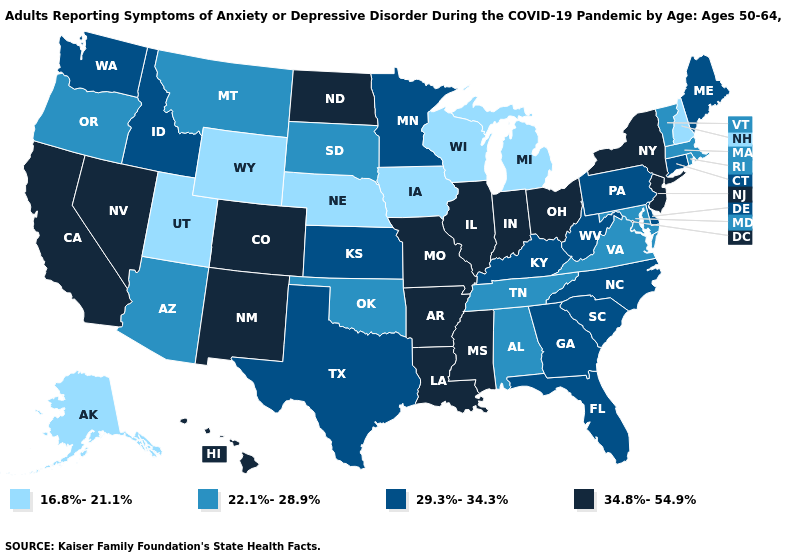Name the states that have a value in the range 29.3%-34.3%?
Quick response, please. Connecticut, Delaware, Florida, Georgia, Idaho, Kansas, Kentucky, Maine, Minnesota, North Carolina, Pennsylvania, South Carolina, Texas, Washington, West Virginia. Among the states that border Minnesota , does North Dakota have the lowest value?
Keep it brief. No. What is the highest value in states that border Indiana?
Answer briefly. 34.8%-54.9%. What is the highest value in the USA?
Answer briefly. 34.8%-54.9%. What is the lowest value in states that border Ohio?
Keep it brief. 16.8%-21.1%. Name the states that have a value in the range 16.8%-21.1%?
Keep it brief. Alaska, Iowa, Michigan, Nebraska, New Hampshire, Utah, Wisconsin, Wyoming. Name the states that have a value in the range 16.8%-21.1%?
Give a very brief answer. Alaska, Iowa, Michigan, Nebraska, New Hampshire, Utah, Wisconsin, Wyoming. Does Massachusetts have the same value as Georgia?
Write a very short answer. No. Name the states that have a value in the range 22.1%-28.9%?
Write a very short answer. Alabama, Arizona, Maryland, Massachusetts, Montana, Oklahoma, Oregon, Rhode Island, South Dakota, Tennessee, Vermont, Virginia. Does Hawaii have a lower value than Nevada?
Write a very short answer. No. What is the value of Nebraska?
Answer briefly. 16.8%-21.1%. Name the states that have a value in the range 29.3%-34.3%?
Answer briefly. Connecticut, Delaware, Florida, Georgia, Idaho, Kansas, Kentucky, Maine, Minnesota, North Carolina, Pennsylvania, South Carolina, Texas, Washington, West Virginia. Name the states that have a value in the range 16.8%-21.1%?
Quick response, please. Alaska, Iowa, Michigan, Nebraska, New Hampshire, Utah, Wisconsin, Wyoming. Among the states that border Florida , which have the lowest value?
Keep it brief. Alabama. Does New Hampshire have the lowest value in the Northeast?
Quick response, please. Yes. 